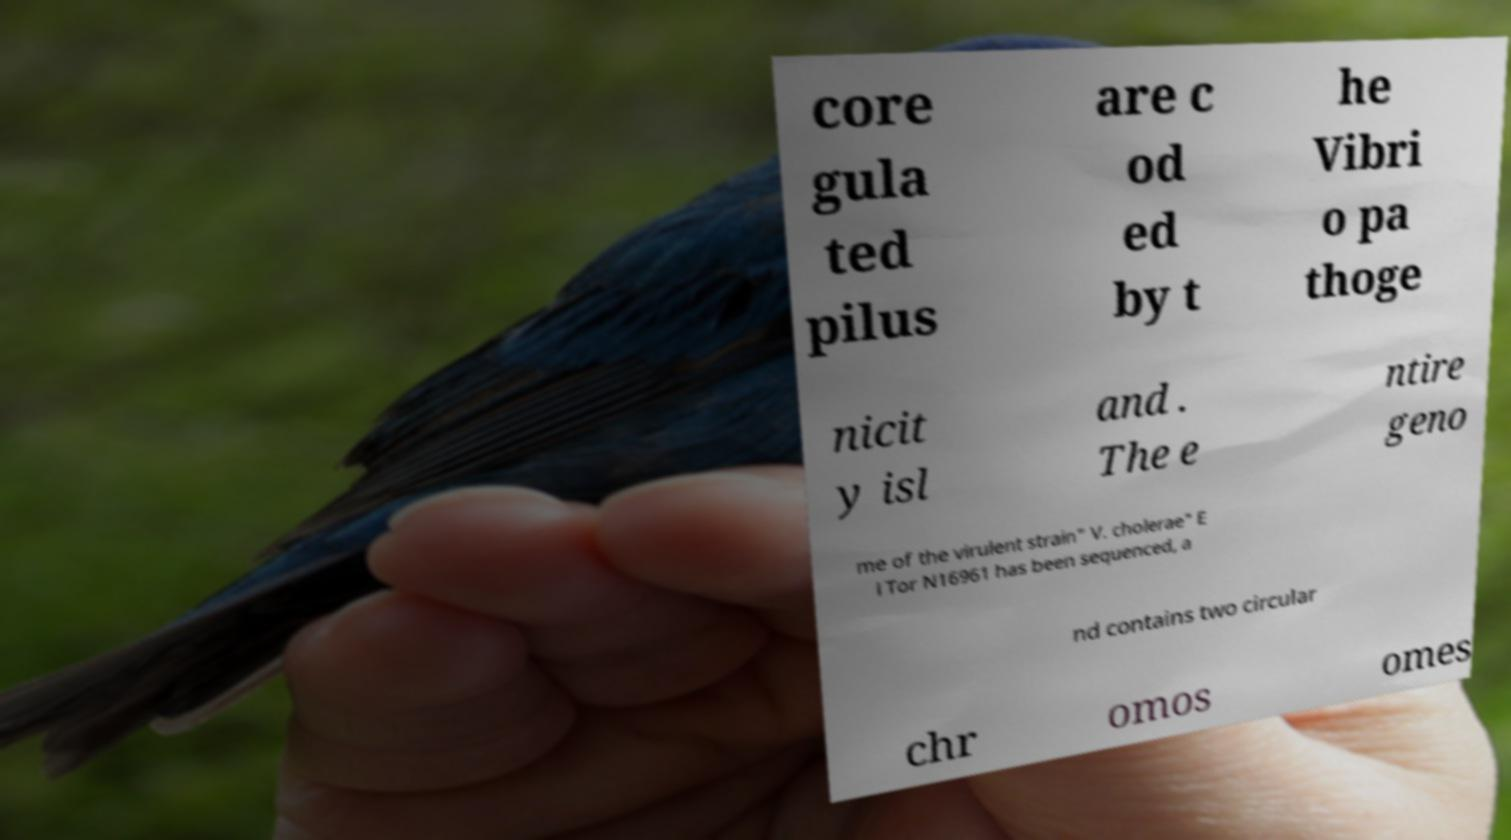Can you read and provide the text displayed in the image?This photo seems to have some interesting text. Can you extract and type it out for me? core gula ted pilus are c od ed by t he Vibri o pa thoge nicit y isl and . The e ntire geno me of the virulent strain" V. cholerae" E l Tor N16961 has been sequenced, a nd contains two circular chr omos omes 